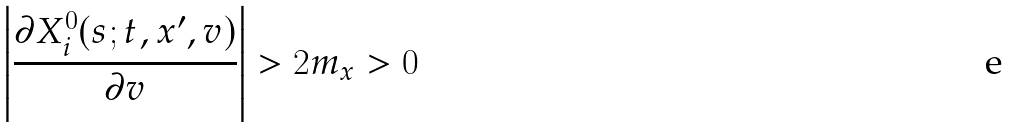Convert formula to latex. <formula><loc_0><loc_0><loc_500><loc_500>\left | \frac { \partial X _ { i } ^ { 0 } ( s ; t , x ^ { \prime } , v ) } { \partial v } \right | > 2 m _ { x } > 0</formula> 